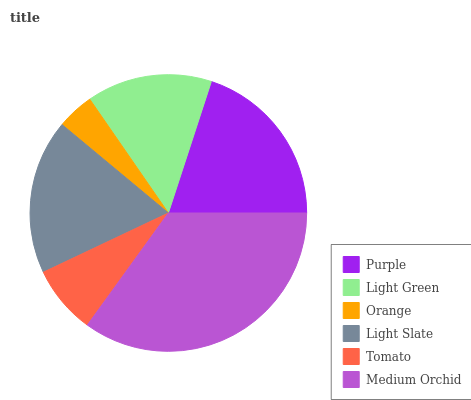Is Orange the minimum?
Answer yes or no. Yes. Is Medium Orchid the maximum?
Answer yes or no. Yes. Is Light Green the minimum?
Answer yes or no. No. Is Light Green the maximum?
Answer yes or no. No. Is Purple greater than Light Green?
Answer yes or no. Yes. Is Light Green less than Purple?
Answer yes or no. Yes. Is Light Green greater than Purple?
Answer yes or no. No. Is Purple less than Light Green?
Answer yes or no. No. Is Light Slate the high median?
Answer yes or no. Yes. Is Light Green the low median?
Answer yes or no. Yes. Is Medium Orchid the high median?
Answer yes or no. No. Is Tomato the low median?
Answer yes or no. No. 